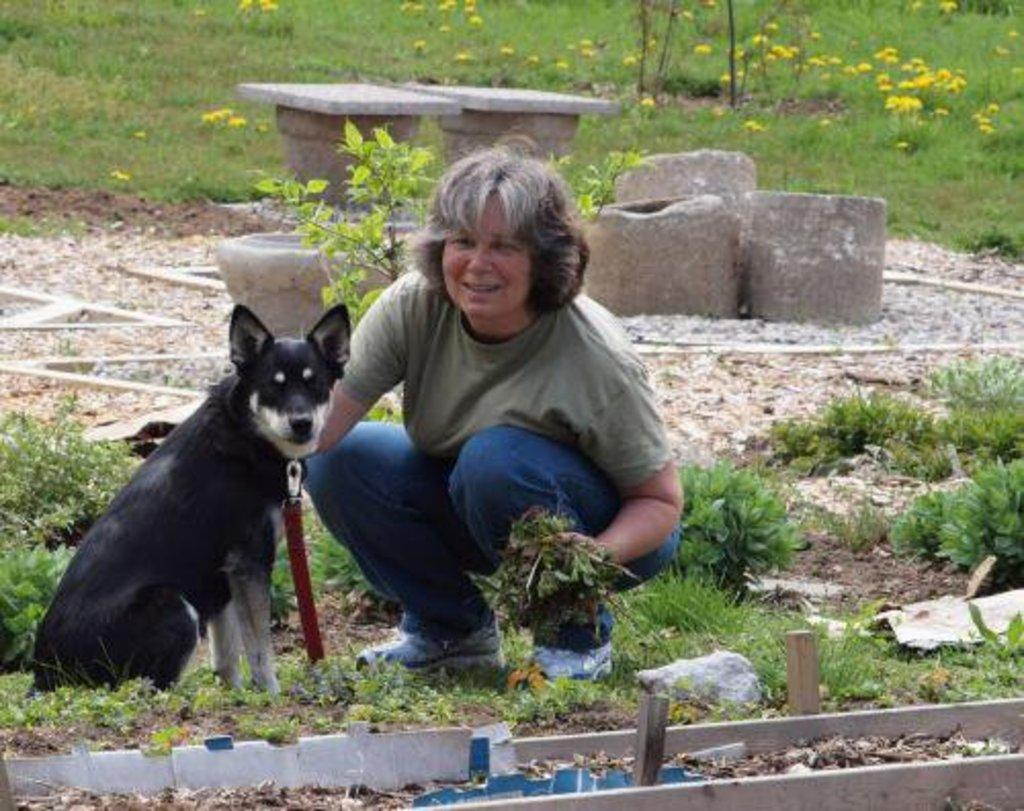What is the main subject of the image? There is a person in the image. What is the person holding in their hand? The person is holding something in their hand, but the specific object is not mentioned in the facts. What other living creature is present in the image? There is a dog in the image. What is unique about the dog's appearance? The dog is wearing a belt. What type of vegetation can be seen in the image? There are plants on the ground in the image. What type of inanimate objects are present in the image? There are stones in the image. What type of zinc is visible in the image? There is no zinc present in the image. What type of sail can be seen in the image? There is no sail present in the image. 